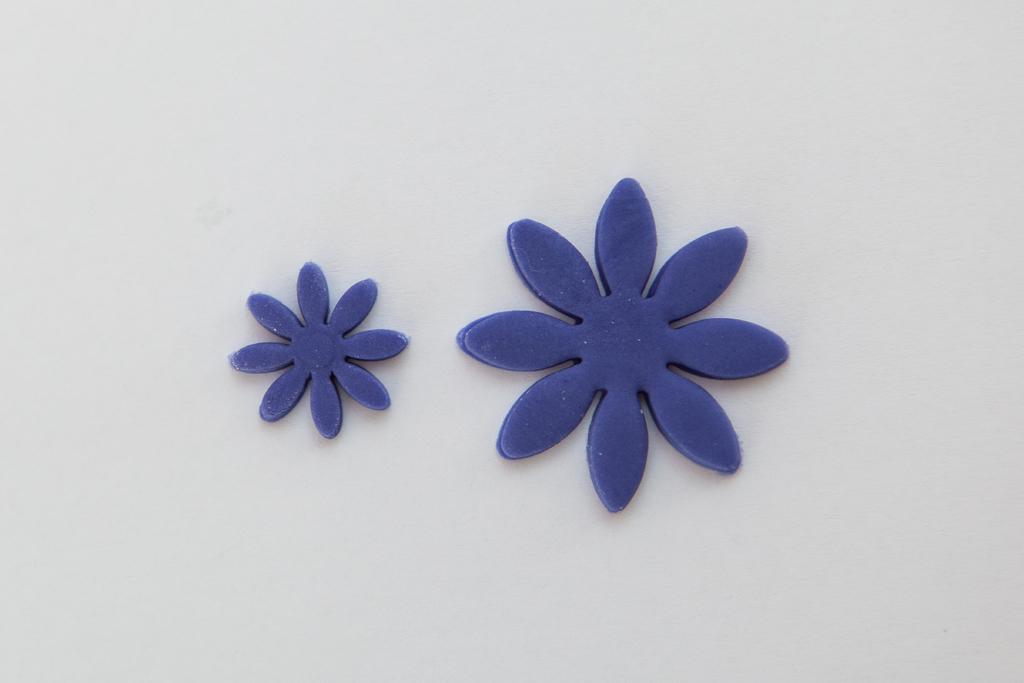What type of objects are present in the image? There are two artificial flowers in the image. Where are the artificial flowers located? The artificial flowers are on an object. How many servants are attending to the artificial flowers in the image? There are no servants present in the image, as it only features artificial flowers on an object. 